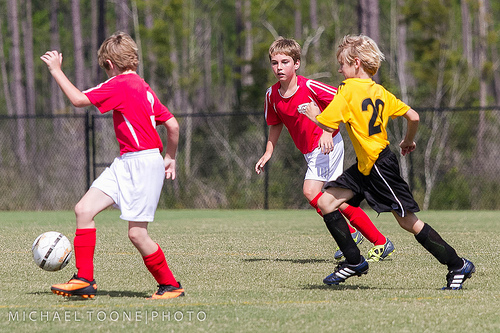<image>
Can you confirm if the fence is behind the boy? Yes. From this viewpoint, the fence is positioned behind the boy, with the boy partially or fully occluding the fence. 